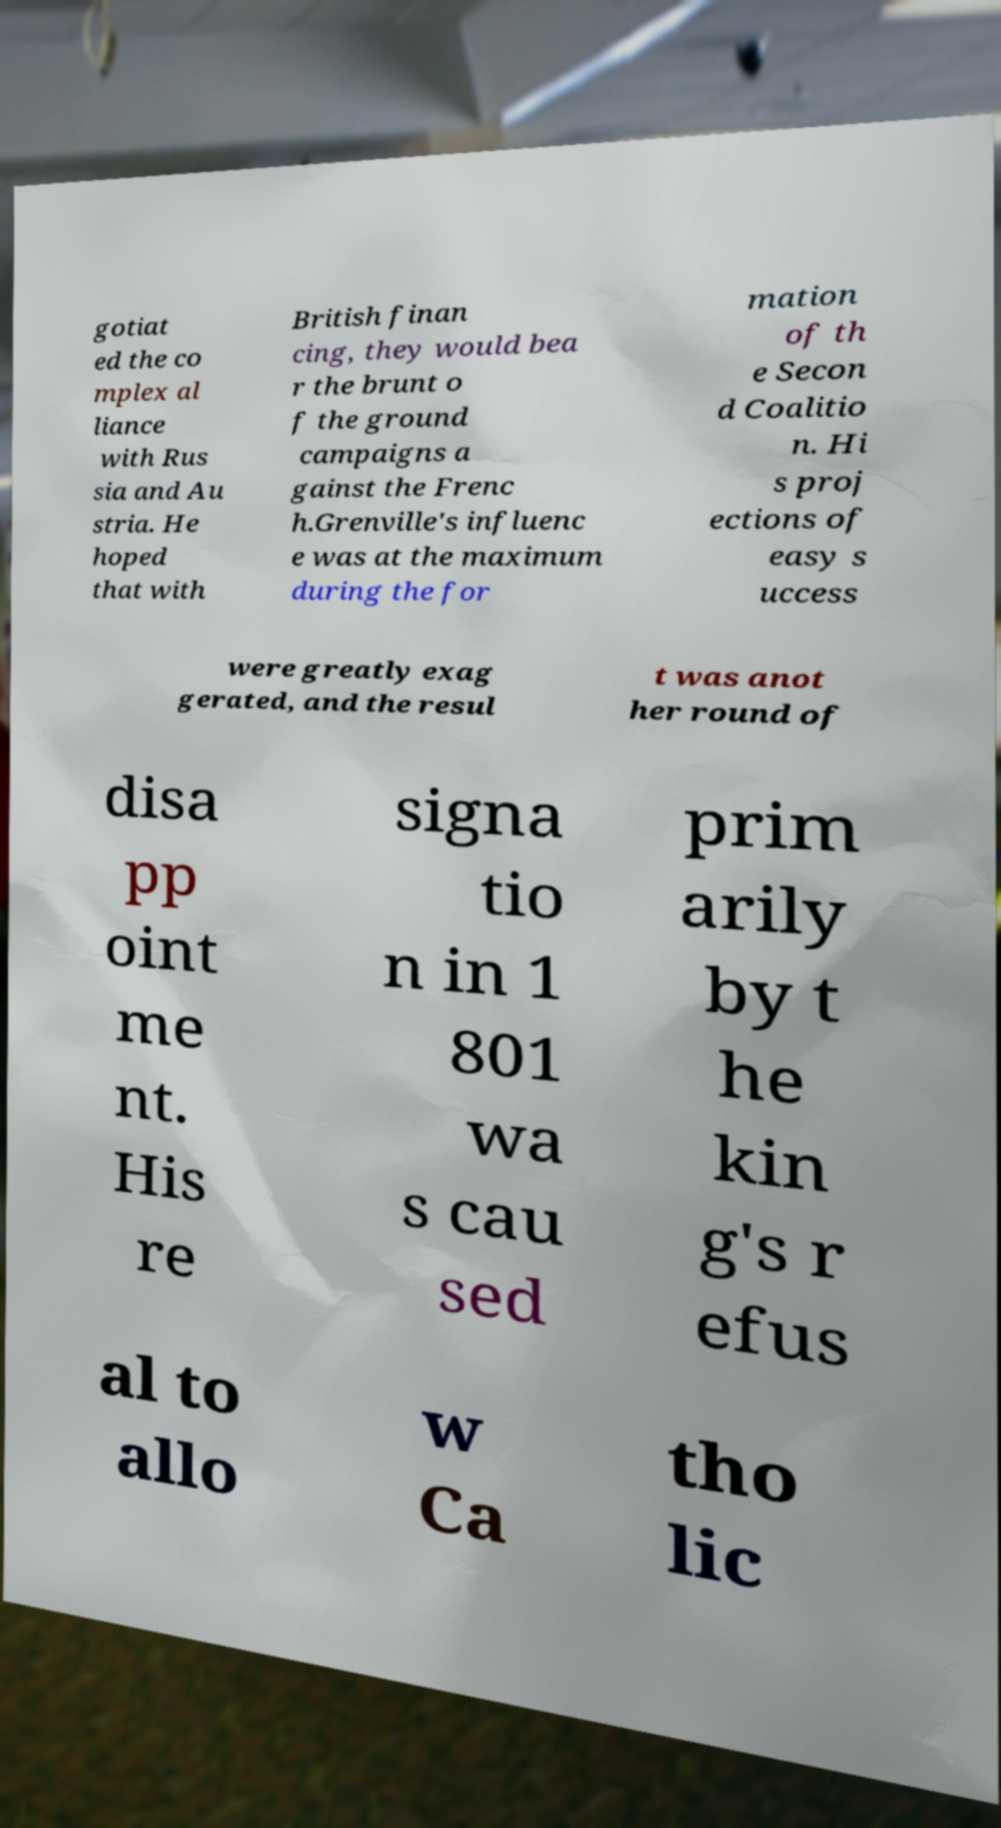I need the written content from this picture converted into text. Can you do that? gotiat ed the co mplex al liance with Rus sia and Au stria. He hoped that with British finan cing, they would bea r the brunt o f the ground campaigns a gainst the Frenc h.Grenville's influenc e was at the maximum during the for mation of th e Secon d Coalitio n. Hi s proj ections of easy s uccess were greatly exag gerated, and the resul t was anot her round of disa pp oint me nt. His re signa tio n in 1 801 wa s cau sed prim arily by t he kin g's r efus al to allo w Ca tho lic 